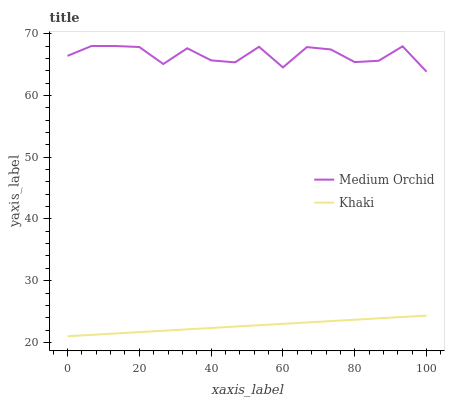Does Khaki have the maximum area under the curve?
Answer yes or no. No. Is Khaki the roughest?
Answer yes or no. No. Does Khaki have the highest value?
Answer yes or no. No. Is Khaki less than Medium Orchid?
Answer yes or no. Yes. Is Medium Orchid greater than Khaki?
Answer yes or no. Yes. Does Khaki intersect Medium Orchid?
Answer yes or no. No. 